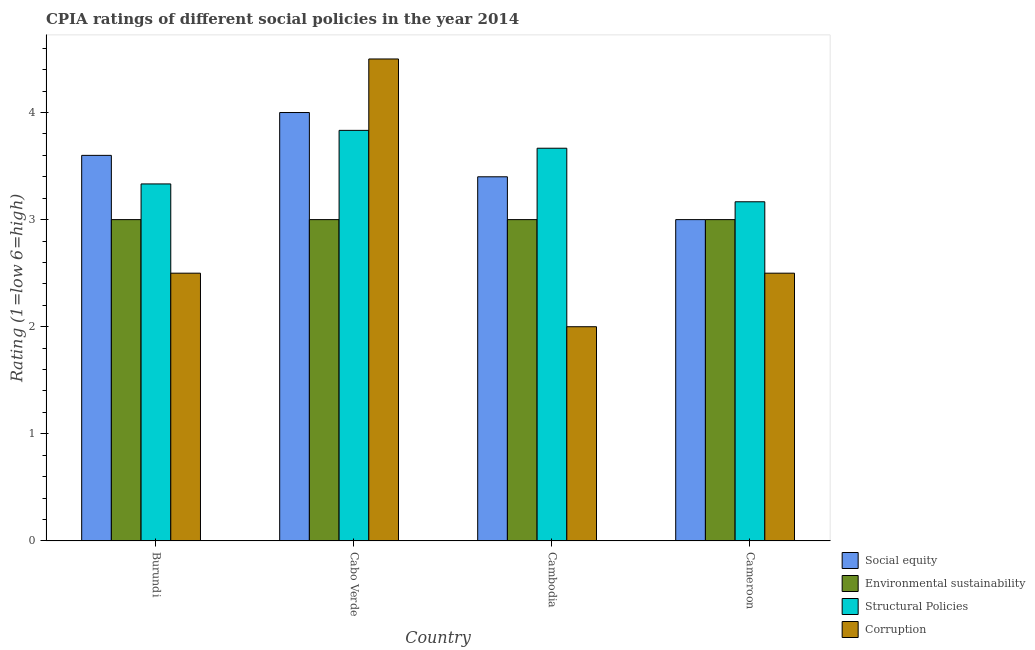Are the number of bars per tick equal to the number of legend labels?
Your response must be concise. Yes. How many bars are there on the 2nd tick from the right?
Provide a short and direct response. 4. What is the label of the 3rd group of bars from the left?
Provide a short and direct response. Cambodia. In how many cases, is the number of bars for a given country not equal to the number of legend labels?
Your answer should be very brief. 0. Across all countries, what is the maximum cpia rating of corruption?
Offer a very short reply. 4.5. Across all countries, what is the minimum cpia rating of corruption?
Your answer should be very brief. 2. In which country was the cpia rating of structural policies maximum?
Offer a very short reply. Cabo Verde. In which country was the cpia rating of corruption minimum?
Your answer should be very brief. Cambodia. What is the difference between the cpia rating of corruption in Cabo Verde and the cpia rating of social equity in Cameroon?
Provide a short and direct response. 1.5. What is the average cpia rating of structural policies per country?
Keep it short and to the point. 3.5. What is the difference between the cpia rating of structural policies and cpia rating of social equity in Cambodia?
Your response must be concise. 0.27. What is the ratio of the cpia rating of corruption in Cabo Verde to that in Cameroon?
Ensure brevity in your answer.  1.8. Is the difference between the cpia rating of corruption in Burundi and Cabo Verde greater than the difference between the cpia rating of structural policies in Burundi and Cabo Verde?
Provide a short and direct response. No. What is the difference between the highest and the second highest cpia rating of environmental sustainability?
Offer a terse response. 0. Is the sum of the cpia rating of corruption in Cabo Verde and Cameroon greater than the maximum cpia rating of structural policies across all countries?
Keep it short and to the point. Yes. What does the 2nd bar from the left in Cambodia represents?
Offer a very short reply. Environmental sustainability. What does the 1st bar from the right in Cabo Verde represents?
Offer a very short reply. Corruption. Are all the bars in the graph horizontal?
Provide a succinct answer. No. Does the graph contain any zero values?
Provide a short and direct response. No. Does the graph contain grids?
Offer a terse response. No. Where does the legend appear in the graph?
Your answer should be compact. Bottom right. How many legend labels are there?
Offer a very short reply. 4. How are the legend labels stacked?
Provide a succinct answer. Vertical. What is the title of the graph?
Your response must be concise. CPIA ratings of different social policies in the year 2014. What is the Rating (1=low 6=high) of Social equity in Burundi?
Make the answer very short. 3.6. What is the Rating (1=low 6=high) of Environmental sustainability in Burundi?
Offer a very short reply. 3. What is the Rating (1=low 6=high) of Structural Policies in Burundi?
Your response must be concise. 3.33. What is the Rating (1=low 6=high) in Social equity in Cabo Verde?
Your answer should be compact. 4. What is the Rating (1=low 6=high) of Environmental sustainability in Cabo Verde?
Offer a terse response. 3. What is the Rating (1=low 6=high) of Structural Policies in Cabo Verde?
Keep it short and to the point. 3.83. What is the Rating (1=low 6=high) in Environmental sustainability in Cambodia?
Make the answer very short. 3. What is the Rating (1=low 6=high) of Structural Policies in Cambodia?
Provide a succinct answer. 3.67. What is the Rating (1=low 6=high) in Corruption in Cambodia?
Provide a succinct answer. 2. What is the Rating (1=low 6=high) in Social equity in Cameroon?
Ensure brevity in your answer.  3. What is the Rating (1=low 6=high) in Structural Policies in Cameroon?
Provide a short and direct response. 3.17. Across all countries, what is the maximum Rating (1=low 6=high) in Social equity?
Provide a succinct answer. 4. Across all countries, what is the maximum Rating (1=low 6=high) of Structural Policies?
Your answer should be compact. 3.83. Across all countries, what is the maximum Rating (1=low 6=high) of Corruption?
Offer a very short reply. 4.5. Across all countries, what is the minimum Rating (1=low 6=high) of Environmental sustainability?
Your response must be concise. 3. Across all countries, what is the minimum Rating (1=low 6=high) in Structural Policies?
Give a very brief answer. 3.17. Across all countries, what is the minimum Rating (1=low 6=high) in Corruption?
Give a very brief answer. 2. What is the total Rating (1=low 6=high) in Social equity in the graph?
Make the answer very short. 14. What is the total Rating (1=low 6=high) of Structural Policies in the graph?
Give a very brief answer. 14. What is the total Rating (1=low 6=high) in Corruption in the graph?
Your response must be concise. 11.5. What is the difference between the Rating (1=low 6=high) in Social equity in Burundi and that in Cabo Verde?
Offer a terse response. -0.4. What is the difference between the Rating (1=low 6=high) in Environmental sustainability in Burundi and that in Cabo Verde?
Make the answer very short. 0. What is the difference between the Rating (1=low 6=high) in Corruption in Burundi and that in Cabo Verde?
Offer a very short reply. -2. What is the difference between the Rating (1=low 6=high) of Corruption in Burundi and that in Cambodia?
Ensure brevity in your answer.  0.5. What is the difference between the Rating (1=low 6=high) of Social equity in Burundi and that in Cameroon?
Give a very brief answer. 0.6. What is the difference between the Rating (1=low 6=high) of Environmental sustainability in Burundi and that in Cameroon?
Keep it short and to the point. 0. What is the difference between the Rating (1=low 6=high) in Structural Policies in Burundi and that in Cameroon?
Keep it short and to the point. 0.17. What is the difference between the Rating (1=low 6=high) in Corruption in Burundi and that in Cameroon?
Give a very brief answer. 0. What is the difference between the Rating (1=low 6=high) in Social equity in Cabo Verde and that in Cambodia?
Your response must be concise. 0.6. What is the difference between the Rating (1=low 6=high) in Corruption in Cabo Verde and that in Cameroon?
Provide a short and direct response. 2. What is the difference between the Rating (1=low 6=high) in Social equity in Cambodia and that in Cameroon?
Keep it short and to the point. 0.4. What is the difference between the Rating (1=low 6=high) of Environmental sustainability in Cambodia and that in Cameroon?
Keep it short and to the point. 0. What is the difference between the Rating (1=low 6=high) of Structural Policies in Cambodia and that in Cameroon?
Provide a succinct answer. 0.5. What is the difference between the Rating (1=low 6=high) in Corruption in Cambodia and that in Cameroon?
Give a very brief answer. -0.5. What is the difference between the Rating (1=low 6=high) in Social equity in Burundi and the Rating (1=low 6=high) in Environmental sustainability in Cabo Verde?
Offer a terse response. 0.6. What is the difference between the Rating (1=low 6=high) of Social equity in Burundi and the Rating (1=low 6=high) of Structural Policies in Cabo Verde?
Your response must be concise. -0.23. What is the difference between the Rating (1=low 6=high) of Social equity in Burundi and the Rating (1=low 6=high) of Corruption in Cabo Verde?
Provide a short and direct response. -0.9. What is the difference between the Rating (1=low 6=high) in Structural Policies in Burundi and the Rating (1=low 6=high) in Corruption in Cabo Verde?
Your answer should be compact. -1.17. What is the difference between the Rating (1=low 6=high) of Social equity in Burundi and the Rating (1=low 6=high) of Environmental sustainability in Cambodia?
Offer a very short reply. 0.6. What is the difference between the Rating (1=low 6=high) in Social equity in Burundi and the Rating (1=low 6=high) in Structural Policies in Cambodia?
Offer a very short reply. -0.07. What is the difference between the Rating (1=low 6=high) in Environmental sustainability in Burundi and the Rating (1=low 6=high) in Structural Policies in Cambodia?
Your response must be concise. -0.67. What is the difference between the Rating (1=low 6=high) of Structural Policies in Burundi and the Rating (1=low 6=high) of Corruption in Cambodia?
Your answer should be compact. 1.33. What is the difference between the Rating (1=low 6=high) in Social equity in Burundi and the Rating (1=low 6=high) in Environmental sustainability in Cameroon?
Offer a very short reply. 0.6. What is the difference between the Rating (1=low 6=high) in Social equity in Burundi and the Rating (1=low 6=high) in Structural Policies in Cameroon?
Keep it short and to the point. 0.43. What is the difference between the Rating (1=low 6=high) in Social equity in Burundi and the Rating (1=low 6=high) in Corruption in Cameroon?
Your answer should be compact. 1.1. What is the difference between the Rating (1=low 6=high) of Environmental sustainability in Burundi and the Rating (1=low 6=high) of Structural Policies in Cameroon?
Make the answer very short. -0.17. What is the difference between the Rating (1=low 6=high) in Environmental sustainability in Burundi and the Rating (1=low 6=high) in Corruption in Cameroon?
Offer a terse response. 0.5. What is the difference between the Rating (1=low 6=high) of Social equity in Cabo Verde and the Rating (1=low 6=high) of Corruption in Cambodia?
Ensure brevity in your answer.  2. What is the difference between the Rating (1=low 6=high) of Environmental sustainability in Cabo Verde and the Rating (1=low 6=high) of Structural Policies in Cambodia?
Make the answer very short. -0.67. What is the difference between the Rating (1=low 6=high) of Environmental sustainability in Cabo Verde and the Rating (1=low 6=high) of Corruption in Cambodia?
Provide a succinct answer. 1. What is the difference between the Rating (1=low 6=high) in Structural Policies in Cabo Verde and the Rating (1=low 6=high) in Corruption in Cambodia?
Make the answer very short. 1.83. What is the difference between the Rating (1=low 6=high) in Social equity in Cabo Verde and the Rating (1=low 6=high) in Environmental sustainability in Cameroon?
Give a very brief answer. 1. What is the difference between the Rating (1=low 6=high) in Social equity in Cabo Verde and the Rating (1=low 6=high) in Structural Policies in Cameroon?
Your response must be concise. 0.83. What is the difference between the Rating (1=low 6=high) of Social equity in Cabo Verde and the Rating (1=low 6=high) of Corruption in Cameroon?
Your answer should be compact. 1.5. What is the difference between the Rating (1=low 6=high) in Structural Policies in Cabo Verde and the Rating (1=low 6=high) in Corruption in Cameroon?
Your response must be concise. 1.33. What is the difference between the Rating (1=low 6=high) of Social equity in Cambodia and the Rating (1=low 6=high) of Structural Policies in Cameroon?
Give a very brief answer. 0.23. What is the difference between the Rating (1=low 6=high) of Environmental sustainability in Cambodia and the Rating (1=low 6=high) of Structural Policies in Cameroon?
Give a very brief answer. -0.17. What is the difference between the Rating (1=low 6=high) of Structural Policies in Cambodia and the Rating (1=low 6=high) of Corruption in Cameroon?
Offer a very short reply. 1.17. What is the average Rating (1=low 6=high) in Social equity per country?
Keep it short and to the point. 3.5. What is the average Rating (1=low 6=high) of Structural Policies per country?
Offer a very short reply. 3.5. What is the average Rating (1=low 6=high) of Corruption per country?
Your answer should be compact. 2.88. What is the difference between the Rating (1=low 6=high) in Social equity and Rating (1=low 6=high) in Environmental sustainability in Burundi?
Give a very brief answer. 0.6. What is the difference between the Rating (1=low 6=high) of Social equity and Rating (1=low 6=high) of Structural Policies in Burundi?
Ensure brevity in your answer.  0.27. What is the difference between the Rating (1=low 6=high) of Environmental sustainability and Rating (1=low 6=high) of Structural Policies in Burundi?
Give a very brief answer. -0.33. What is the difference between the Rating (1=low 6=high) in Social equity and Rating (1=low 6=high) in Structural Policies in Cabo Verde?
Offer a terse response. 0.17. What is the difference between the Rating (1=low 6=high) in Social equity and Rating (1=low 6=high) in Corruption in Cabo Verde?
Your answer should be compact. -0.5. What is the difference between the Rating (1=low 6=high) of Environmental sustainability and Rating (1=low 6=high) of Corruption in Cabo Verde?
Your answer should be very brief. -1.5. What is the difference between the Rating (1=low 6=high) of Social equity and Rating (1=low 6=high) of Structural Policies in Cambodia?
Your answer should be compact. -0.27. What is the difference between the Rating (1=low 6=high) of Social equity and Rating (1=low 6=high) of Corruption in Cambodia?
Make the answer very short. 1.4. What is the difference between the Rating (1=low 6=high) of Environmental sustainability and Rating (1=low 6=high) of Corruption in Cambodia?
Provide a short and direct response. 1. What is the difference between the Rating (1=low 6=high) in Social equity and Rating (1=low 6=high) in Corruption in Cameroon?
Give a very brief answer. 0.5. What is the difference between the Rating (1=low 6=high) of Environmental sustainability and Rating (1=low 6=high) of Corruption in Cameroon?
Your answer should be compact. 0.5. What is the ratio of the Rating (1=low 6=high) in Social equity in Burundi to that in Cabo Verde?
Offer a terse response. 0.9. What is the ratio of the Rating (1=low 6=high) of Structural Policies in Burundi to that in Cabo Verde?
Keep it short and to the point. 0.87. What is the ratio of the Rating (1=low 6=high) in Corruption in Burundi to that in Cabo Verde?
Offer a terse response. 0.56. What is the ratio of the Rating (1=low 6=high) of Social equity in Burundi to that in Cambodia?
Your answer should be very brief. 1.06. What is the ratio of the Rating (1=low 6=high) in Environmental sustainability in Burundi to that in Cambodia?
Offer a very short reply. 1. What is the ratio of the Rating (1=low 6=high) in Structural Policies in Burundi to that in Cambodia?
Provide a short and direct response. 0.91. What is the ratio of the Rating (1=low 6=high) of Corruption in Burundi to that in Cambodia?
Provide a succinct answer. 1.25. What is the ratio of the Rating (1=low 6=high) in Social equity in Burundi to that in Cameroon?
Keep it short and to the point. 1.2. What is the ratio of the Rating (1=low 6=high) in Environmental sustainability in Burundi to that in Cameroon?
Your answer should be compact. 1. What is the ratio of the Rating (1=low 6=high) in Structural Policies in Burundi to that in Cameroon?
Offer a terse response. 1.05. What is the ratio of the Rating (1=low 6=high) of Corruption in Burundi to that in Cameroon?
Keep it short and to the point. 1. What is the ratio of the Rating (1=low 6=high) of Social equity in Cabo Verde to that in Cambodia?
Keep it short and to the point. 1.18. What is the ratio of the Rating (1=low 6=high) in Structural Policies in Cabo Verde to that in Cambodia?
Make the answer very short. 1.05. What is the ratio of the Rating (1=low 6=high) in Corruption in Cabo Verde to that in Cambodia?
Provide a short and direct response. 2.25. What is the ratio of the Rating (1=low 6=high) of Social equity in Cabo Verde to that in Cameroon?
Provide a short and direct response. 1.33. What is the ratio of the Rating (1=low 6=high) in Environmental sustainability in Cabo Verde to that in Cameroon?
Give a very brief answer. 1. What is the ratio of the Rating (1=low 6=high) of Structural Policies in Cabo Verde to that in Cameroon?
Keep it short and to the point. 1.21. What is the ratio of the Rating (1=low 6=high) in Social equity in Cambodia to that in Cameroon?
Your answer should be compact. 1.13. What is the ratio of the Rating (1=low 6=high) of Environmental sustainability in Cambodia to that in Cameroon?
Your response must be concise. 1. What is the ratio of the Rating (1=low 6=high) in Structural Policies in Cambodia to that in Cameroon?
Offer a very short reply. 1.16. What is the difference between the highest and the second highest Rating (1=low 6=high) in Social equity?
Your answer should be compact. 0.4. What is the difference between the highest and the second highest Rating (1=low 6=high) in Environmental sustainability?
Offer a terse response. 0. What is the difference between the highest and the second highest Rating (1=low 6=high) in Structural Policies?
Ensure brevity in your answer.  0.17. What is the difference between the highest and the second highest Rating (1=low 6=high) of Corruption?
Offer a very short reply. 2. What is the difference between the highest and the lowest Rating (1=low 6=high) in Social equity?
Provide a succinct answer. 1. What is the difference between the highest and the lowest Rating (1=low 6=high) of Structural Policies?
Offer a very short reply. 0.67. 